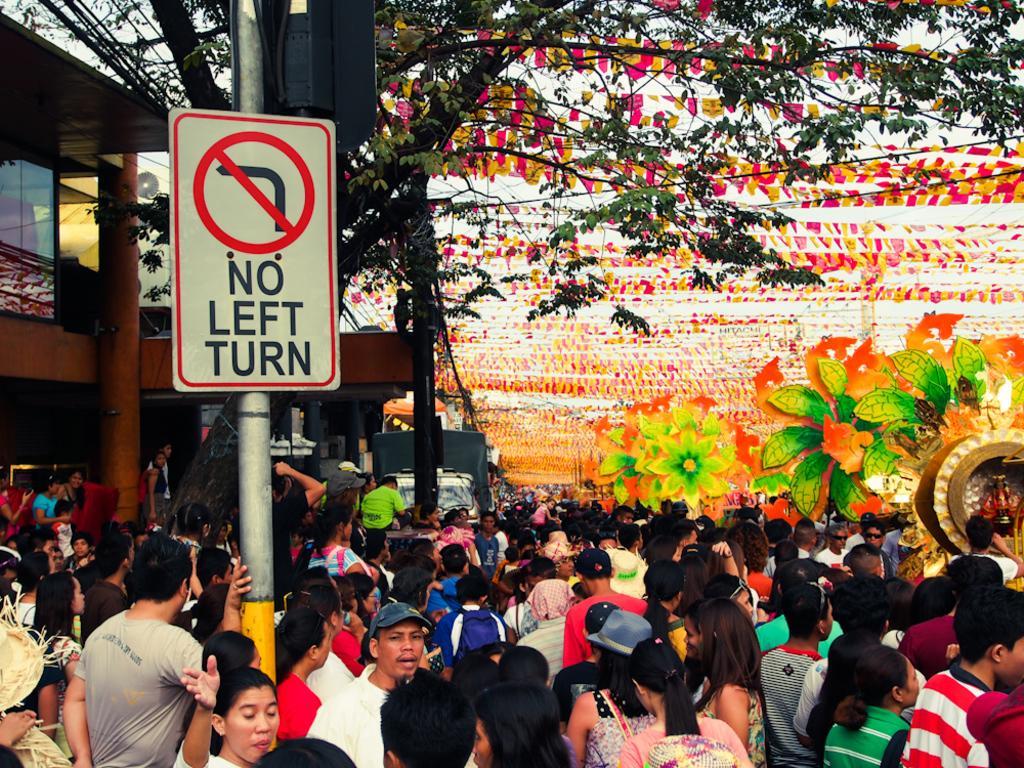In one or two sentences, can you explain what this image depicts? In this image, there are a few people, buildings. We can see a pole with some objects like a signboard. We can see some ribbons and a vehicle. We can also see an idol in an object. We can see some flower crafts, trees and a vehicle. 